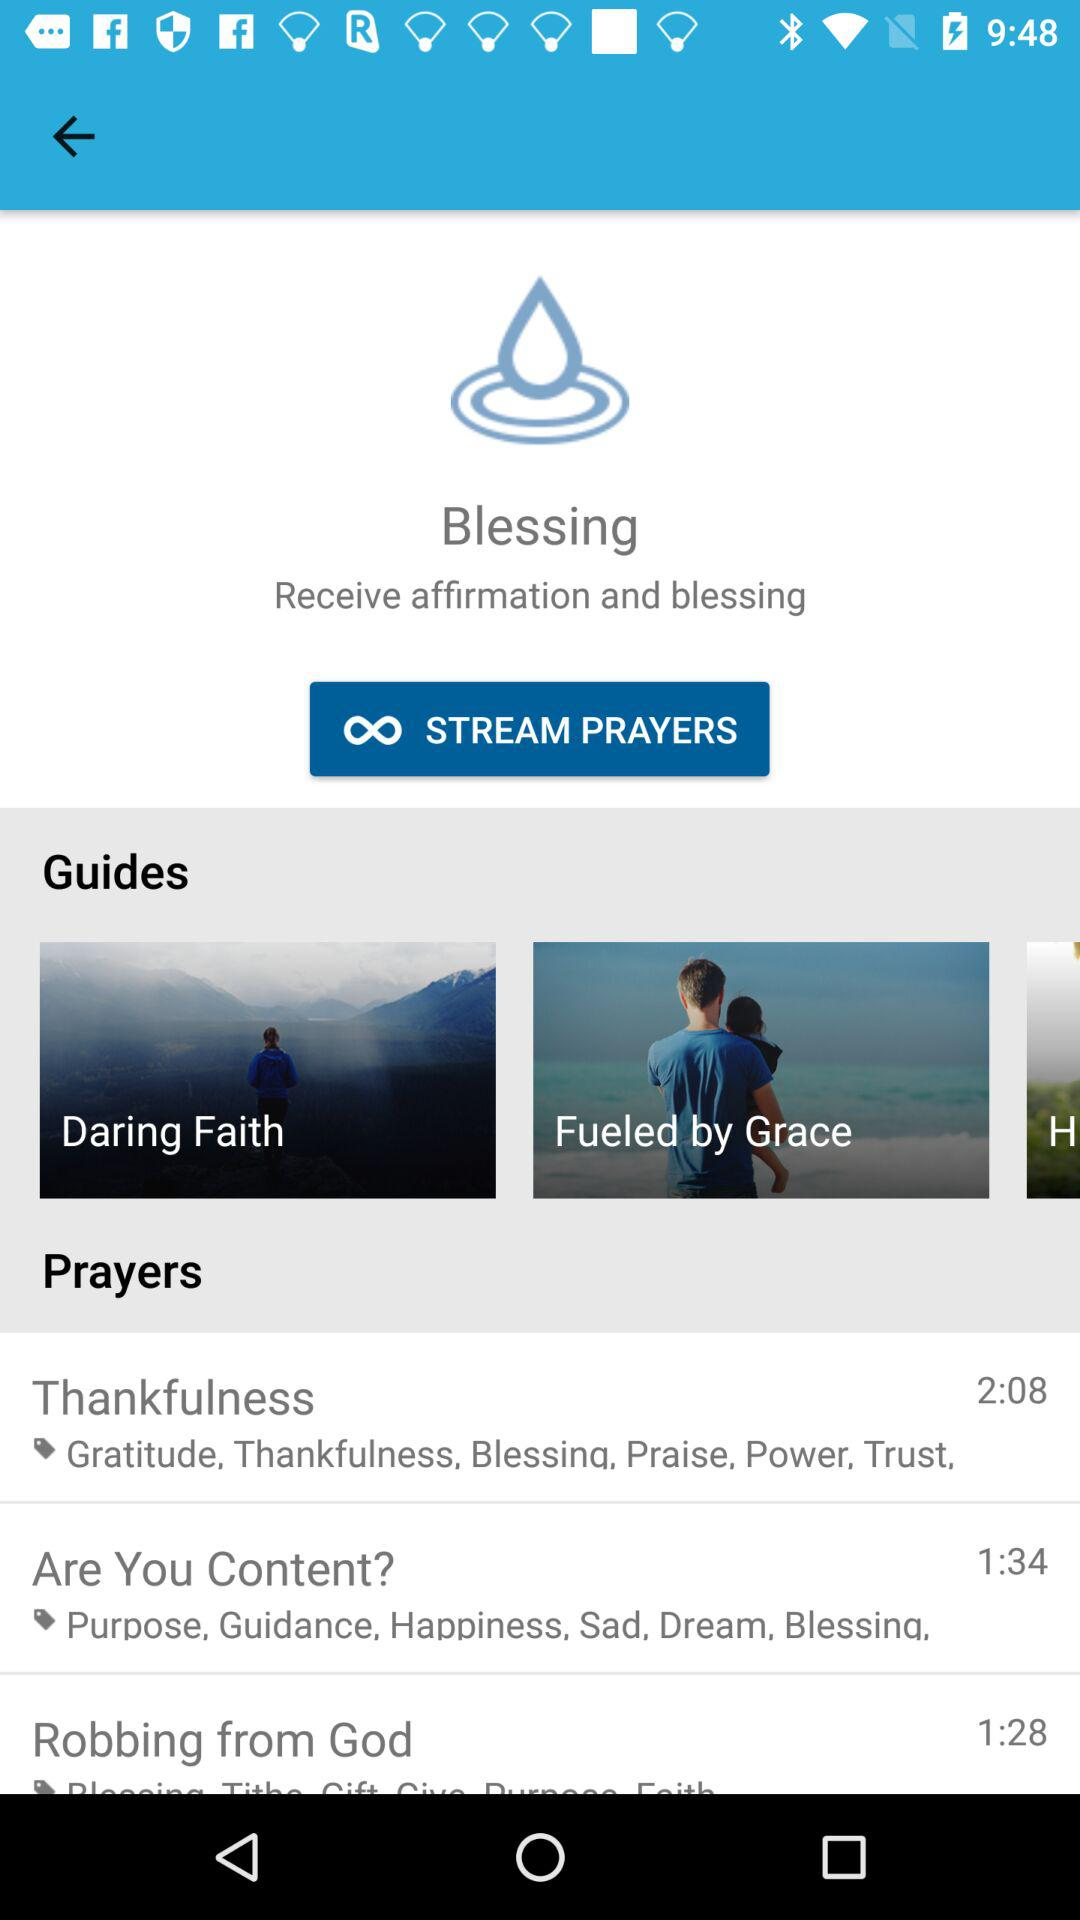How many prayers are there on this screen?
Answer the question using a single word or phrase. 3 